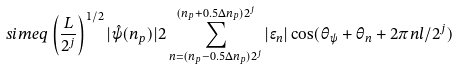Convert formula to latex. <formula><loc_0><loc_0><loc_500><loc_500>\quad s i m e q \left ( \frac { L } { 2 ^ { j } } \right ) ^ { 1 / 2 } | \hat { \psi } ( n _ { p } ) | 2 \sum _ { n = ( n _ { p } - 0 . 5 \Delta n _ { p } ) 2 ^ { j } } ^ { ( n _ { p } + 0 . 5 \Delta n _ { p } ) 2 ^ { j } } | \epsilon _ { n } | \cos ( \theta _ { \psi } + \theta _ { n } + 2 \pi n l / 2 ^ { j } )</formula> 